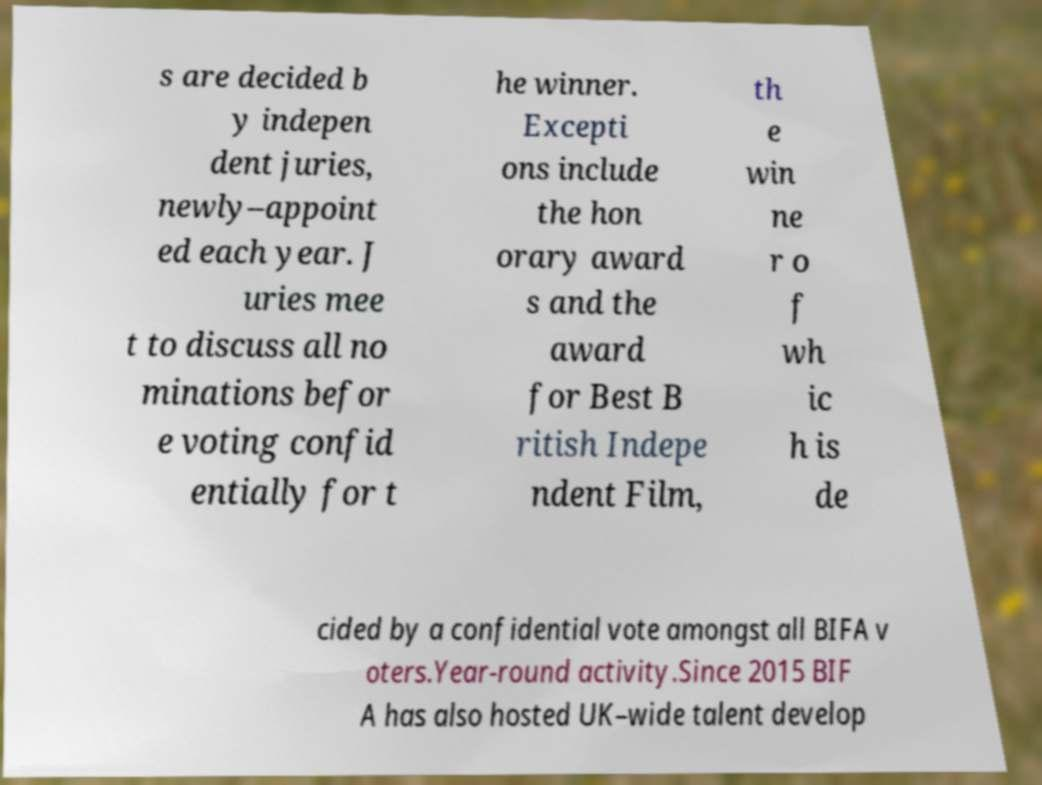Could you extract and type out the text from this image? s are decided b y indepen dent juries, newly–appoint ed each year. J uries mee t to discuss all no minations befor e voting confid entially for t he winner. Excepti ons include the hon orary award s and the award for Best B ritish Indepe ndent Film, th e win ne r o f wh ic h is de cided by a confidential vote amongst all BIFA v oters.Year-round activity.Since 2015 BIF A has also hosted UK–wide talent develop 